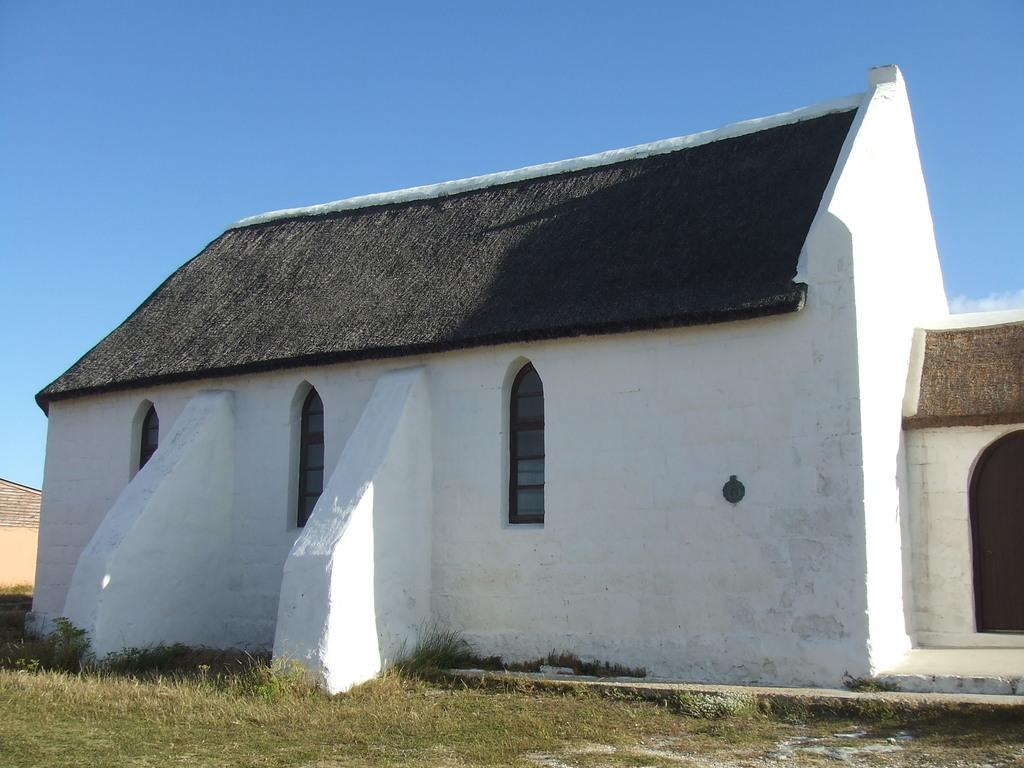What type of vegetation can be seen in the image? There is grass in the image. What type of structure is present in the image? There is a house in the image. What can be seen in the background of the image? The sky is visible in the background of the image. Can you tell me how many people are having trouble with their tongues while swimming in the image? There are no people or swimming activities present in the image, so this question cannot be answered. 